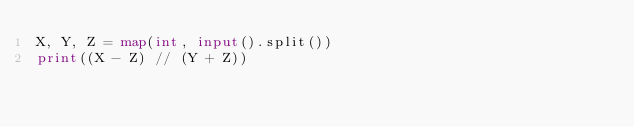<code> <loc_0><loc_0><loc_500><loc_500><_Python_>X, Y, Z = map(int, input().split())
print((X - Z) // (Y + Z))
</code> 